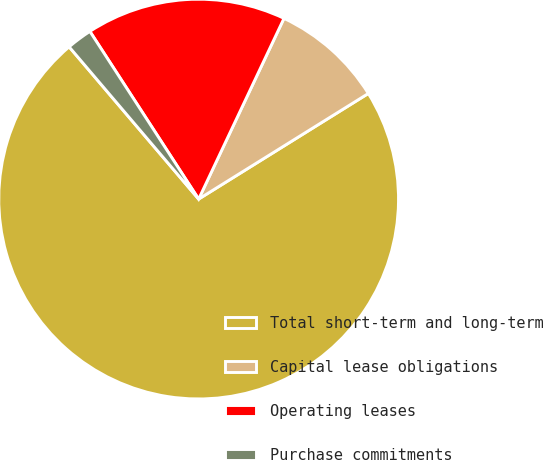Convert chart to OTSL. <chart><loc_0><loc_0><loc_500><loc_500><pie_chart><fcel>Total short-term and long-term<fcel>Capital lease obligations<fcel>Operating leases<fcel>Purchase commitments<nl><fcel>72.65%<fcel>9.12%<fcel>16.18%<fcel>2.06%<nl></chart> 